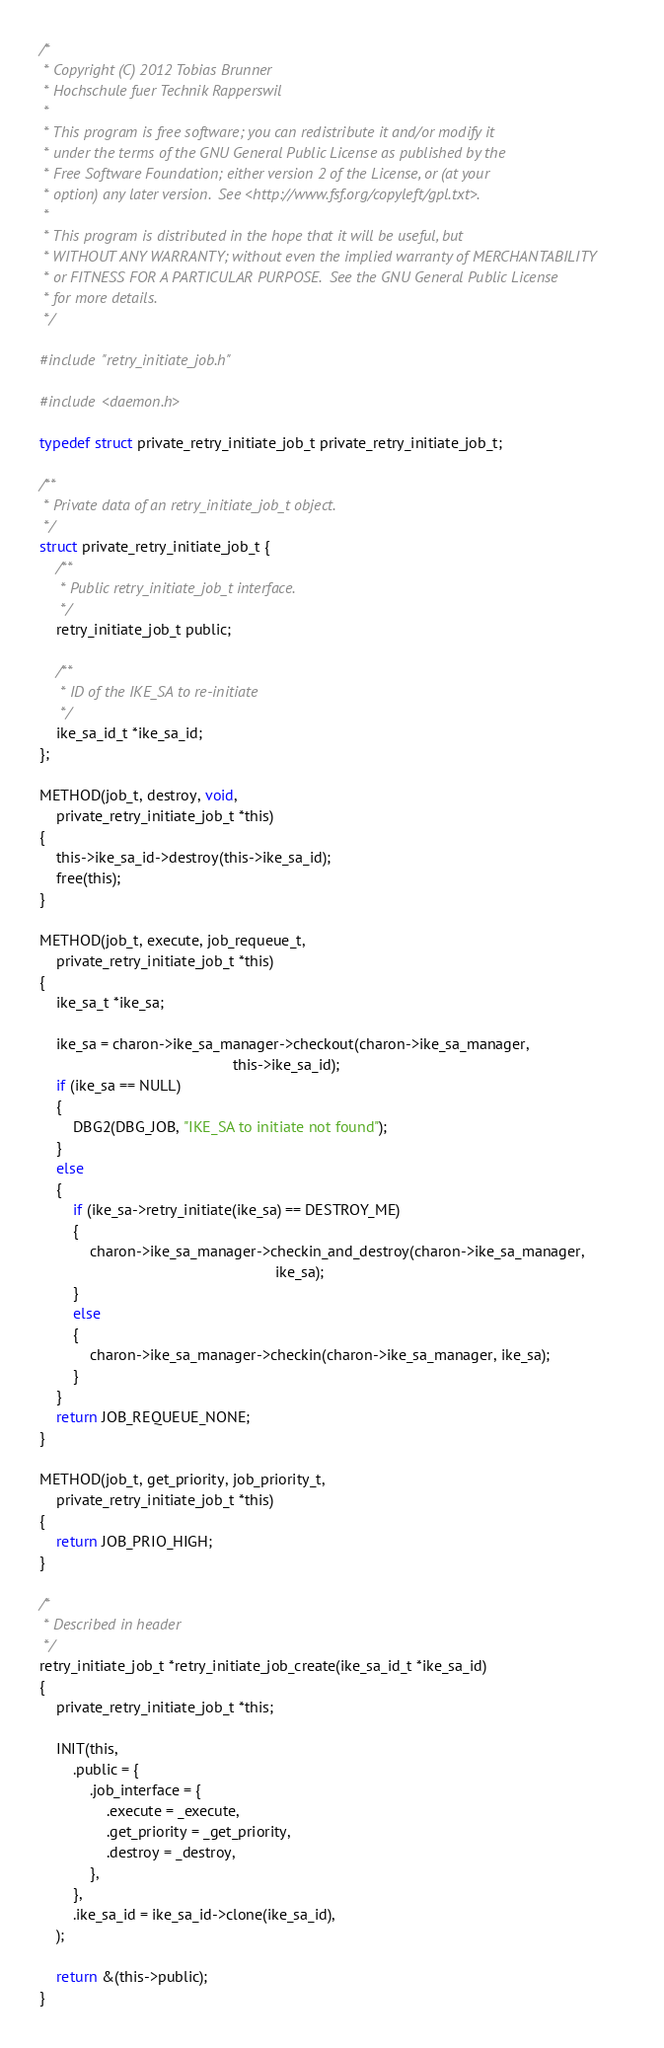Convert code to text. <code><loc_0><loc_0><loc_500><loc_500><_C_>/*
 * Copyright (C) 2012 Tobias Brunner
 * Hochschule fuer Technik Rapperswil
 *
 * This program is free software; you can redistribute it and/or modify it
 * under the terms of the GNU General Public License as published by the
 * Free Software Foundation; either version 2 of the License, or (at your
 * option) any later version.  See <http://www.fsf.org/copyleft/gpl.txt>.
 *
 * This program is distributed in the hope that it will be useful, but
 * WITHOUT ANY WARRANTY; without even the implied warranty of MERCHANTABILITY
 * or FITNESS FOR A PARTICULAR PURPOSE.  See the GNU General Public License
 * for more details.
 */

#include "retry_initiate_job.h"

#include <daemon.h>

typedef struct private_retry_initiate_job_t private_retry_initiate_job_t;

/**
 * Private data of an retry_initiate_job_t object.
 */
struct private_retry_initiate_job_t {
	/**
	 * Public retry_initiate_job_t interface.
	 */
	retry_initiate_job_t public;

	/**
	 * ID of the IKE_SA to re-initiate
	 */
	ike_sa_id_t *ike_sa_id;
};

METHOD(job_t, destroy, void,
	private_retry_initiate_job_t *this)
{
	this->ike_sa_id->destroy(this->ike_sa_id);
	free(this);
}

METHOD(job_t, execute, job_requeue_t,
	private_retry_initiate_job_t *this)
{
	ike_sa_t *ike_sa;

	ike_sa = charon->ike_sa_manager->checkout(charon->ike_sa_manager,
											  this->ike_sa_id);
	if (ike_sa == NULL)
	{
		DBG2(DBG_JOB, "IKE_SA to initiate not found");
	}
	else
	{
		if (ike_sa->retry_initiate(ike_sa) == DESTROY_ME)
		{
			charon->ike_sa_manager->checkin_and_destroy(charon->ike_sa_manager,
														ike_sa);
		}
		else
		{
			charon->ike_sa_manager->checkin(charon->ike_sa_manager, ike_sa);
		}
	}
	return JOB_REQUEUE_NONE;
}

METHOD(job_t, get_priority, job_priority_t,
	private_retry_initiate_job_t *this)
{
	return JOB_PRIO_HIGH;
}

/*
 * Described in header
 */
retry_initiate_job_t *retry_initiate_job_create(ike_sa_id_t *ike_sa_id)
{
	private_retry_initiate_job_t *this;

	INIT(this,
		.public = {
			.job_interface = {
				.execute = _execute,
				.get_priority = _get_priority,
				.destroy = _destroy,
			},
		},
		.ike_sa_id = ike_sa_id->clone(ike_sa_id),
	);

	return &(this->public);
}
</code> 